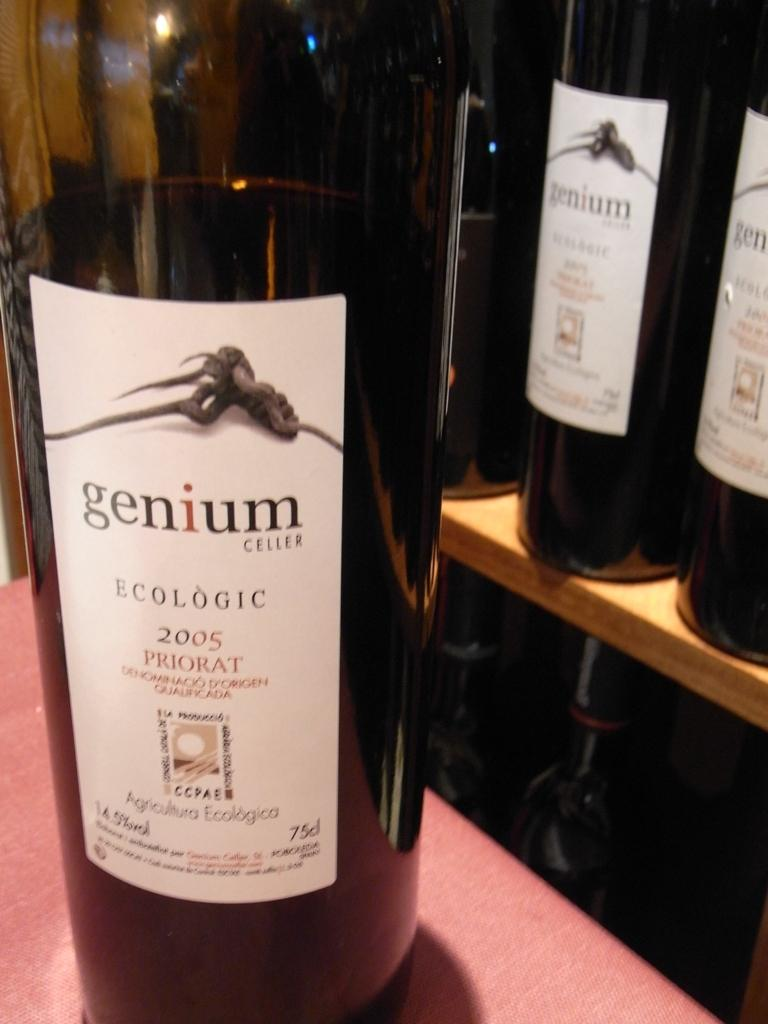<image>
Describe the image concisely. A bottle of genium Celler ecologic wine on a table. 